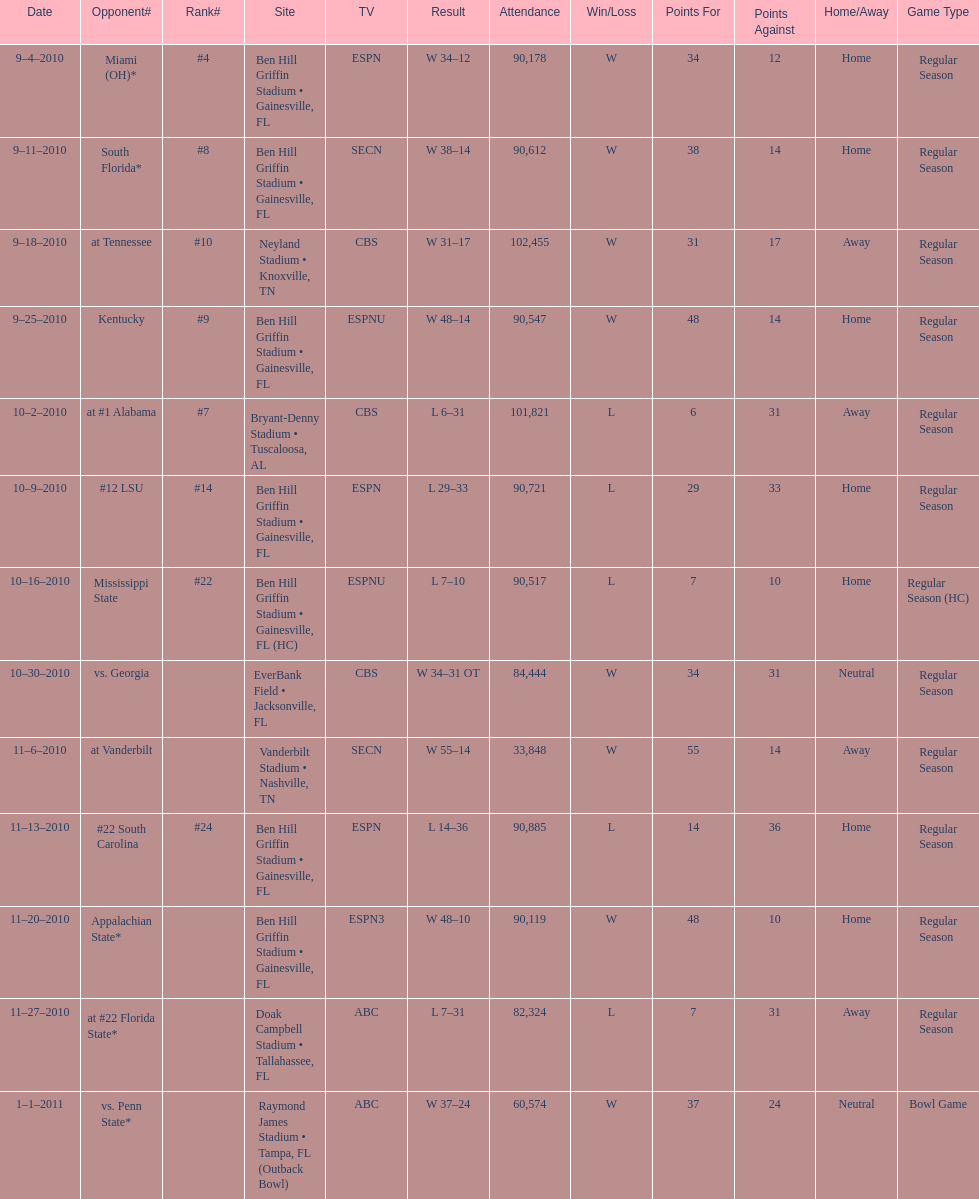Can you parse all the data within this table? {'header': ['Date', 'Opponent#', 'Rank#', 'Site', 'TV', 'Result', 'Attendance', 'Win/Loss', 'Points For', 'Points Against', 'Home/Away', 'Game Type'], 'rows': [['9–4–2010', 'Miami (OH)*', '#4', 'Ben Hill Griffin Stadium • Gainesville, FL', 'ESPN', 'W\xa034–12', '90,178', 'W', '34', '12', 'Home', 'Regular Season'], ['9–11–2010', 'South Florida*', '#8', 'Ben Hill Griffin Stadium • Gainesville, FL', 'SECN', 'W\xa038–14', '90,612', 'W', '38', '14', 'Home', 'Regular Season'], ['9–18–2010', 'at\xa0Tennessee', '#10', 'Neyland Stadium • Knoxville, TN', 'CBS', 'W\xa031–17', '102,455', 'W', '31', '17', 'Away', 'Regular Season'], ['9–25–2010', 'Kentucky', '#9', 'Ben Hill Griffin Stadium • Gainesville, FL', 'ESPNU', 'W\xa048–14', '90,547', 'W', '48', '14', 'Home', 'Regular Season'], ['10–2–2010', 'at\xa0#1\xa0Alabama', '#7', 'Bryant-Denny Stadium • Tuscaloosa, AL', 'CBS', 'L\xa06–31', '101,821', 'L', '6', '31', 'Away', 'Regular Season'], ['10–9–2010', '#12\xa0LSU', '#14', 'Ben Hill Griffin Stadium • Gainesville, FL', 'ESPN', 'L\xa029–33', '90,721', 'L', '29', '33', 'Home', 'Regular Season'], ['10–16–2010', 'Mississippi State', '#22', 'Ben Hill Griffin Stadium • Gainesville, FL (HC)', 'ESPNU', 'L\xa07–10', '90,517', 'L', '7', '10', 'Home', 'Regular Season (HC)'], ['10–30–2010', 'vs.\xa0Georgia', '', 'EverBank Field • Jacksonville, FL', 'CBS', 'W\xa034–31\xa0OT', '84,444', 'W', '34', '31', 'Neutral', 'Regular Season'], ['11–6–2010', 'at\xa0Vanderbilt', '', 'Vanderbilt Stadium • Nashville, TN', 'SECN', 'W\xa055–14', '33,848', 'W', '55', '14', 'Away', 'Regular Season'], ['11–13–2010', '#22\xa0South Carolina', '#24', 'Ben Hill Griffin Stadium • Gainesville, FL', 'ESPN', 'L\xa014–36', '90,885', 'L', '14', '36', 'Home', 'Regular Season'], ['11–20–2010', 'Appalachian State*', '', 'Ben Hill Griffin Stadium • Gainesville, FL', 'ESPN3', 'W\xa048–10', '90,119', 'W', '48', '10', 'Home', 'Regular Season'], ['11–27–2010', 'at\xa0#22\xa0Florida State*', '', 'Doak Campbell Stadium • Tallahassee, FL', 'ABC', 'L\xa07–31', '82,324', 'L', '7', '31', 'Away', 'Regular Season'], ['1–1–2011', 'vs.\xa0Penn State*', '', 'Raymond James Stadium • Tampa, FL (Outback Bowl)', 'ABC', 'W\xa037–24', '60,574', 'W', '37', '24', 'Neutral', 'Bowl Game']]} How many consecutive weeks did the the gators win until the had their first lost in the 2010 season? 4. 